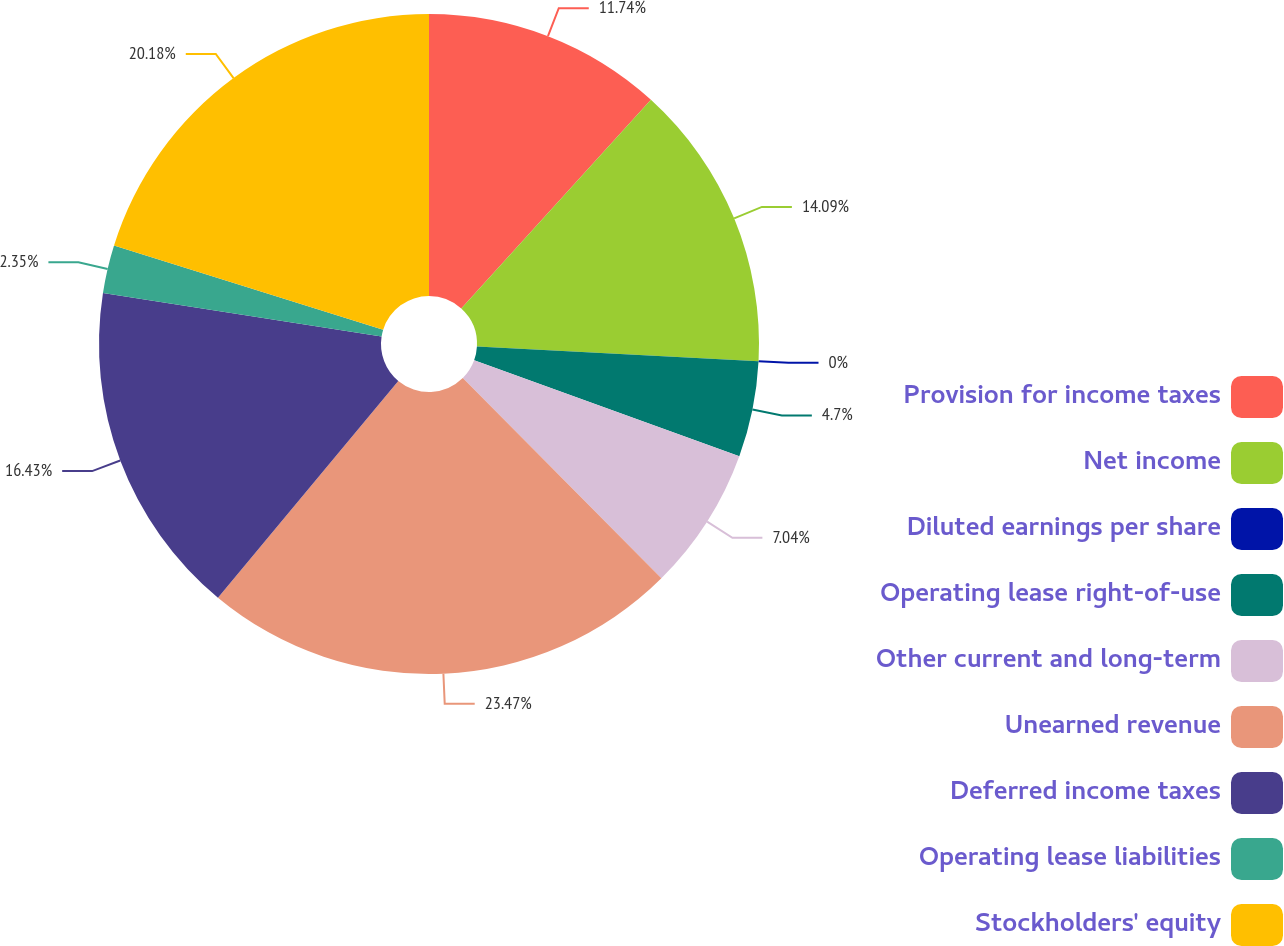Convert chart. <chart><loc_0><loc_0><loc_500><loc_500><pie_chart><fcel>Provision for income taxes<fcel>Net income<fcel>Diluted earnings per share<fcel>Operating lease right-of-use<fcel>Other current and long-term<fcel>Unearned revenue<fcel>Deferred income taxes<fcel>Operating lease liabilities<fcel>Stockholders' equity<nl><fcel>11.74%<fcel>14.09%<fcel>0.0%<fcel>4.7%<fcel>7.04%<fcel>23.48%<fcel>16.43%<fcel>2.35%<fcel>20.18%<nl></chart> 